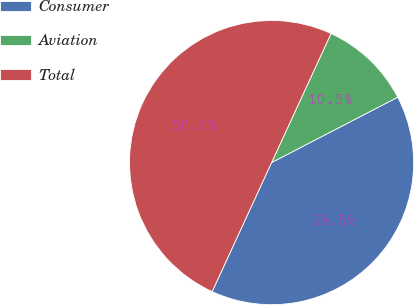Convert chart to OTSL. <chart><loc_0><loc_0><loc_500><loc_500><pie_chart><fcel>Consumer<fcel>Aviation<fcel>Total<nl><fcel>39.48%<fcel>10.52%<fcel>50.0%<nl></chart> 